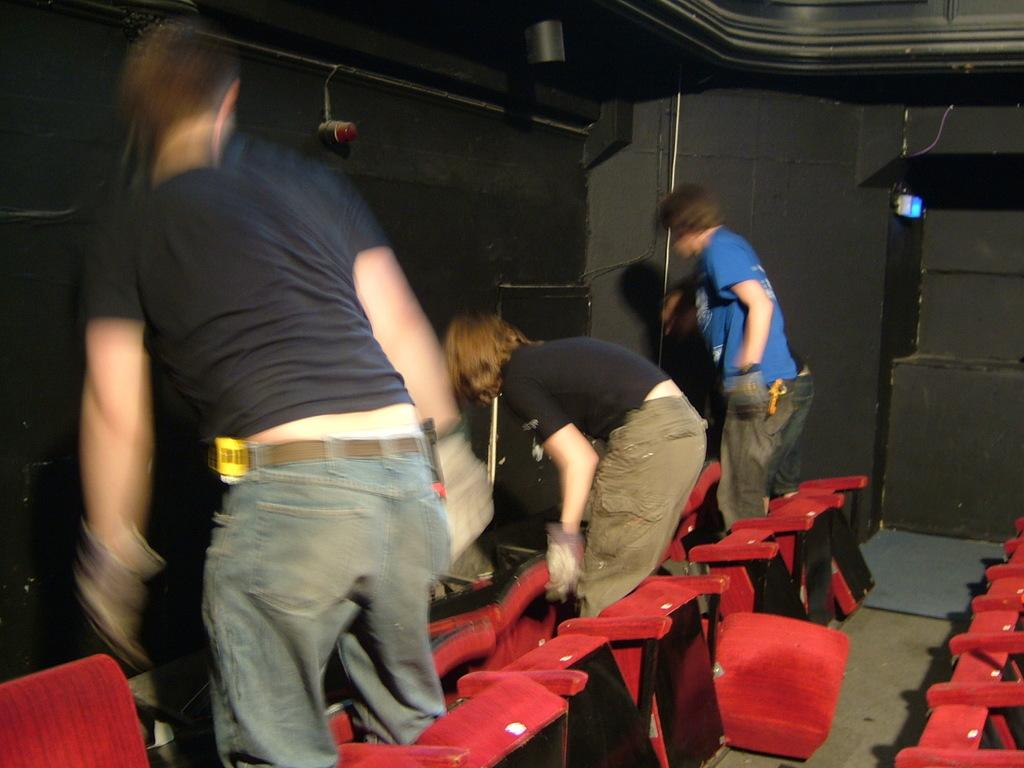How many men are present in the image? There are three men standing in the image. What can be seen in the image besides the men? There are red chairs and lights visible in the image. What color are the chairs in the image? The chairs in the image are red in color. Where are the lights located in the image? The lights are visible at the top of the image and are attached to the wall. What type of fang can be seen growing out of the wall in the image? There is no fang or growth present in the image; it only features three men, red chairs, and lights attached to the wall. 